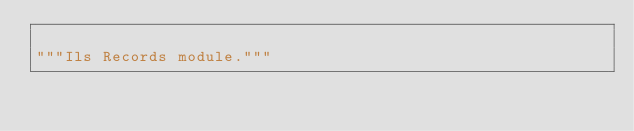<code> <loc_0><loc_0><loc_500><loc_500><_Python_>
"""Ils Records module."""
</code> 